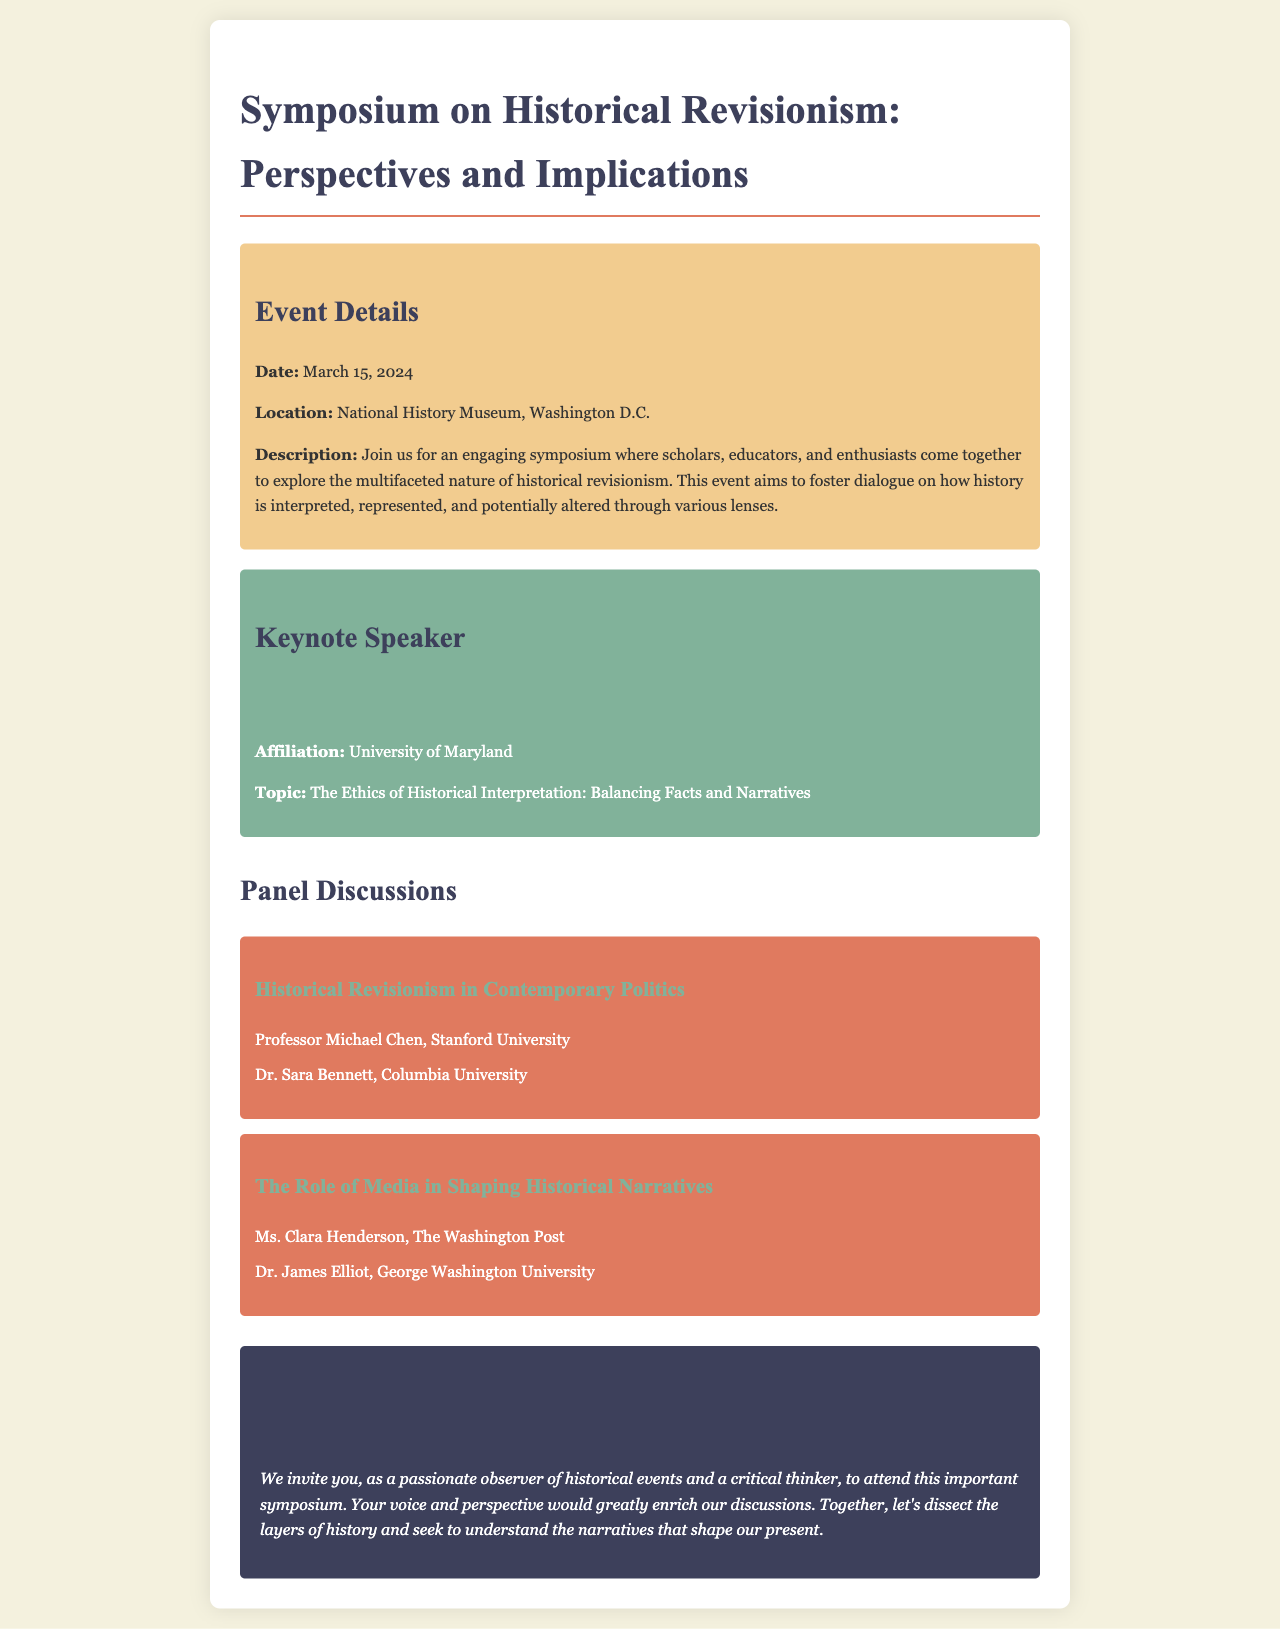What is the date of the symposium? The date of the symposium is clearly stated in the event details section of the document.
Answer: March 15, 2024 Where is the symposium taking place? The location of the symposium is mentioned in the event details section of the document.
Answer: National History Museum, Washington D.C Who is the keynote speaker? The keynote speaker's name is provided in the keynote section of the document.
Answer: Dr. Emily Roberts What is the topic of the keynote speech? The topic of the keynote speech is listed under the keynote speaker section of the document.
Answer: The Ethics of Historical Interpretation: Balancing Facts and Narratives Which university is Professor Michael Chen affiliated with? Professor Michael Chen's affiliation is specified in the panel discussions section of the document.
Answer: Stanford University What is the focus of the panel titled "Historical Revisionism in Contemporary Politics"? The focus of this panel is indicated by its title, which reflects the subject matter discussed.
Answer: Contemporary Politics How many panel discussions are mentioned in the document? The number of panel discussions is determined by counting the distinct panels listed in the document.
Answer: Two What type of event is being hosted? The event type is described in the document's title and description section.
Answer: Symposium Why is the audience invited to join the symposium? The audience is invited for specific reasons stated in the call to action section of the document.
Answer: To enrich discussions 